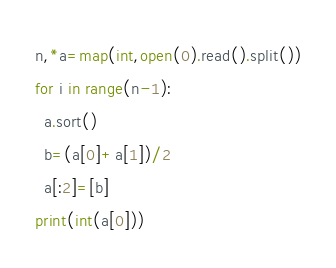<code> <loc_0><loc_0><loc_500><loc_500><_Python_>n,*a=map(int,open(0).read().split())
for i in range(n-1):
  a.sort()
  b=(a[0]+a[1])/2
  a[:2]=[b]
print(int(a[0])) </code> 